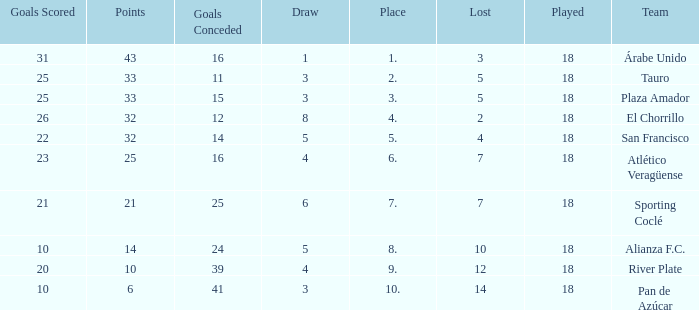How many goals were conceded by the team with more than 21 points more than 5 draws and less than 18 games played? None. I'm looking to parse the entire table for insights. Could you assist me with that? {'header': ['Goals Scored', 'Points', 'Goals Conceded', 'Draw', 'Place', 'Lost', 'Played', 'Team'], 'rows': [['31', '43', '16', '1', '1.', '3', '18', 'Árabe Unido'], ['25', '33', '11', '3', '2.', '5', '18', 'Tauro'], ['25', '33', '15', '3', '3.', '5', '18', 'Plaza Amador'], ['26', '32', '12', '8', '4.', '2', '18', 'El Chorrillo'], ['22', '32', '14', '5', '5.', '4', '18', 'San Francisco'], ['23', '25', '16', '4', '6.', '7', '18', 'Atlético Veragüense'], ['21', '21', '25', '6', '7.', '7', '18', 'Sporting Coclé'], ['10', '14', '24', '5', '8.', '10', '18', 'Alianza F.C.'], ['20', '10', '39', '4', '9.', '12', '18', 'River Plate'], ['10', '6', '41', '3', '10.', '14', '18', 'Pan de Azúcar']]} 